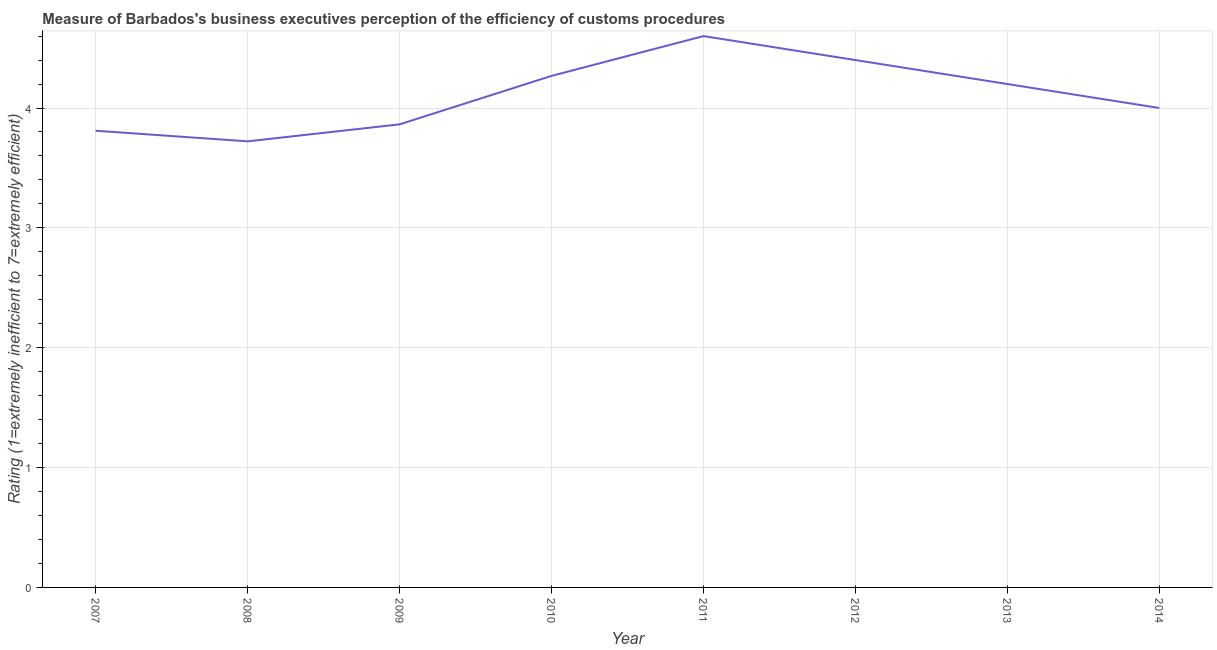Across all years, what is the minimum rating measuring burden of customs procedure?
Your response must be concise. 3.72. In which year was the rating measuring burden of customs procedure minimum?
Offer a terse response. 2008. What is the sum of the rating measuring burden of customs procedure?
Provide a short and direct response. 32.86. What is the difference between the rating measuring burden of customs procedure in 2008 and 2012?
Your response must be concise. -0.68. What is the average rating measuring burden of customs procedure per year?
Provide a short and direct response. 4.11. In how many years, is the rating measuring burden of customs procedure greater than 1.8 ?
Make the answer very short. 8. What is the ratio of the rating measuring burden of customs procedure in 2007 to that in 2008?
Ensure brevity in your answer.  1.02. What is the difference between the highest and the second highest rating measuring burden of customs procedure?
Your answer should be compact. 0.2. What is the difference between the highest and the lowest rating measuring burden of customs procedure?
Offer a terse response. 0.88. Are the values on the major ticks of Y-axis written in scientific E-notation?
Offer a very short reply. No. Does the graph contain any zero values?
Your response must be concise. No. Does the graph contain grids?
Make the answer very short. Yes. What is the title of the graph?
Offer a terse response. Measure of Barbados's business executives perception of the efficiency of customs procedures. What is the label or title of the X-axis?
Keep it short and to the point. Year. What is the label or title of the Y-axis?
Your response must be concise. Rating (1=extremely inefficient to 7=extremely efficient). What is the Rating (1=extremely inefficient to 7=extremely efficient) of 2007?
Provide a succinct answer. 3.81. What is the Rating (1=extremely inefficient to 7=extremely efficient) in 2008?
Your response must be concise. 3.72. What is the Rating (1=extremely inefficient to 7=extremely efficient) of 2009?
Your response must be concise. 3.86. What is the Rating (1=extremely inefficient to 7=extremely efficient) in 2010?
Provide a succinct answer. 4.27. What is the Rating (1=extremely inefficient to 7=extremely efficient) of 2012?
Provide a succinct answer. 4.4. What is the Rating (1=extremely inefficient to 7=extremely efficient) of 2014?
Give a very brief answer. 4. What is the difference between the Rating (1=extremely inefficient to 7=extremely efficient) in 2007 and 2008?
Provide a succinct answer. 0.09. What is the difference between the Rating (1=extremely inefficient to 7=extremely efficient) in 2007 and 2009?
Provide a succinct answer. -0.05. What is the difference between the Rating (1=extremely inefficient to 7=extremely efficient) in 2007 and 2010?
Provide a succinct answer. -0.46. What is the difference between the Rating (1=extremely inefficient to 7=extremely efficient) in 2007 and 2011?
Your answer should be compact. -0.79. What is the difference between the Rating (1=extremely inefficient to 7=extremely efficient) in 2007 and 2012?
Offer a terse response. -0.59. What is the difference between the Rating (1=extremely inefficient to 7=extremely efficient) in 2007 and 2013?
Provide a short and direct response. -0.39. What is the difference between the Rating (1=extremely inefficient to 7=extremely efficient) in 2007 and 2014?
Make the answer very short. -0.19. What is the difference between the Rating (1=extremely inefficient to 7=extremely efficient) in 2008 and 2009?
Keep it short and to the point. -0.14. What is the difference between the Rating (1=extremely inefficient to 7=extremely efficient) in 2008 and 2010?
Your answer should be compact. -0.55. What is the difference between the Rating (1=extremely inefficient to 7=extremely efficient) in 2008 and 2011?
Your answer should be very brief. -0.88. What is the difference between the Rating (1=extremely inefficient to 7=extremely efficient) in 2008 and 2012?
Offer a very short reply. -0.68. What is the difference between the Rating (1=extremely inefficient to 7=extremely efficient) in 2008 and 2013?
Offer a very short reply. -0.48. What is the difference between the Rating (1=extremely inefficient to 7=extremely efficient) in 2008 and 2014?
Offer a very short reply. -0.28. What is the difference between the Rating (1=extremely inefficient to 7=extremely efficient) in 2009 and 2010?
Provide a succinct answer. -0.4. What is the difference between the Rating (1=extremely inefficient to 7=extremely efficient) in 2009 and 2011?
Your answer should be very brief. -0.74. What is the difference between the Rating (1=extremely inefficient to 7=extremely efficient) in 2009 and 2012?
Provide a succinct answer. -0.54. What is the difference between the Rating (1=extremely inefficient to 7=extremely efficient) in 2009 and 2013?
Make the answer very short. -0.34. What is the difference between the Rating (1=extremely inefficient to 7=extremely efficient) in 2009 and 2014?
Provide a short and direct response. -0.14. What is the difference between the Rating (1=extremely inefficient to 7=extremely efficient) in 2010 and 2011?
Offer a very short reply. -0.33. What is the difference between the Rating (1=extremely inefficient to 7=extremely efficient) in 2010 and 2012?
Make the answer very short. -0.13. What is the difference between the Rating (1=extremely inefficient to 7=extremely efficient) in 2010 and 2013?
Provide a short and direct response. 0.07. What is the difference between the Rating (1=extremely inefficient to 7=extremely efficient) in 2010 and 2014?
Offer a terse response. 0.27. What is the difference between the Rating (1=extremely inefficient to 7=extremely efficient) in 2011 and 2013?
Your answer should be compact. 0.4. What is the difference between the Rating (1=extremely inefficient to 7=extremely efficient) in 2011 and 2014?
Offer a very short reply. 0.6. What is the difference between the Rating (1=extremely inefficient to 7=extremely efficient) in 2012 and 2014?
Provide a short and direct response. 0.4. What is the difference between the Rating (1=extremely inefficient to 7=extremely efficient) in 2013 and 2014?
Ensure brevity in your answer.  0.2. What is the ratio of the Rating (1=extremely inefficient to 7=extremely efficient) in 2007 to that in 2008?
Offer a terse response. 1.02. What is the ratio of the Rating (1=extremely inefficient to 7=extremely efficient) in 2007 to that in 2009?
Your answer should be compact. 0.99. What is the ratio of the Rating (1=extremely inefficient to 7=extremely efficient) in 2007 to that in 2010?
Your answer should be very brief. 0.89. What is the ratio of the Rating (1=extremely inefficient to 7=extremely efficient) in 2007 to that in 2011?
Your answer should be compact. 0.83. What is the ratio of the Rating (1=extremely inefficient to 7=extremely efficient) in 2007 to that in 2012?
Offer a terse response. 0.87. What is the ratio of the Rating (1=extremely inefficient to 7=extremely efficient) in 2007 to that in 2013?
Make the answer very short. 0.91. What is the ratio of the Rating (1=extremely inefficient to 7=extremely efficient) in 2007 to that in 2014?
Your response must be concise. 0.95. What is the ratio of the Rating (1=extremely inefficient to 7=extremely efficient) in 2008 to that in 2010?
Your answer should be very brief. 0.87. What is the ratio of the Rating (1=extremely inefficient to 7=extremely efficient) in 2008 to that in 2011?
Keep it short and to the point. 0.81. What is the ratio of the Rating (1=extremely inefficient to 7=extremely efficient) in 2008 to that in 2012?
Offer a terse response. 0.85. What is the ratio of the Rating (1=extremely inefficient to 7=extremely efficient) in 2008 to that in 2013?
Your response must be concise. 0.89. What is the ratio of the Rating (1=extremely inefficient to 7=extremely efficient) in 2008 to that in 2014?
Provide a short and direct response. 0.93. What is the ratio of the Rating (1=extremely inefficient to 7=extremely efficient) in 2009 to that in 2010?
Your answer should be compact. 0.91. What is the ratio of the Rating (1=extremely inefficient to 7=extremely efficient) in 2009 to that in 2011?
Your answer should be compact. 0.84. What is the ratio of the Rating (1=extremely inefficient to 7=extremely efficient) in 2009 to that in 2012?
Ensure brevity in your answer.  0.88. What is the ratio of the Rating (1=extremely inefficient to 7=extremely efficient) in 2009 to that in 2013?
Your answer should be very brief. 0.92. What is the ratio of the Rating (1=extremely inefficient to 7=extremely efficient) in 2009 to that in 2014?
Offer a very short reply. 0.97. What is the ratio of the Rating (1=extremely inefficient to 7=extremely efficient) in 2010 to that in 2011?
Your response must be concise. 0.93. What is the ratio of the Rating (1=extremely inefficient to 7=extremely efficient) in 2010 to that in 2014?
Offer a terse response. 1.07. What is the ratio of the Rating (1=extremely inefficient to 7=extremely efficient) in 2011 to that in 2012?
Give a very brief answer. 1.04. What is the ratio of the Rating (1=extremely inefficient to 7=extremely efficient) in 2011 to that in 2013?
Keep it short and to the point. 1.09. What is the ratio of the Rating (1=extremely inefficient to 7=extremely efficient) in 2011 to that in 2014?
Ensure brevity in your answer.  1.15. What is the ratio of the Rating (1=extremely inefficient to 7=extremely efficient) in 2012 to that in 2013?
Your response must be concise. 1.05. What is the ratio of the Rating (1=extremely inefficient to 7=extremely efficient) in 2013 to that in 2014?
Your response must be concise. 1.05. 